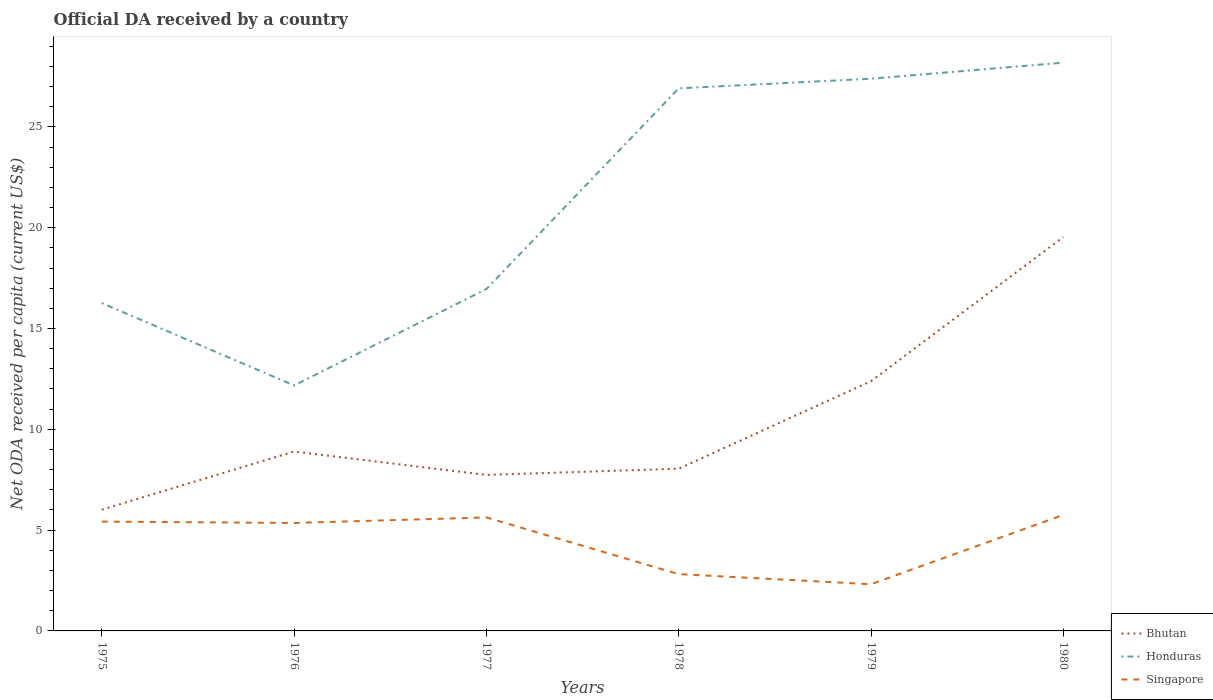Is the number of lines equal to the number of legend labels?
Offer a terse response. Yes. Across all years, what is the maximum ODA received in in Singapore?
Offer a terse response. 2.32. In which year was the ODA received in in Honduras maximum?
Provide a succinct answer. 1976. What is the total ODA received in in Singapore in the graph?
Keep it short and to the point. -0.27. What is the difference between the highest and the second highest ODA received in in Singapore?
Provide a short and direct response. 3.44. What is the difference between the highest and the lowest ODA received in in Singapore?
Provide a succinct answer. 4. Is the ODA received in in Singapore strictly greater than the ODA received in in Honduras over the years?
Provide a succinct answer. Yes. How many lines are there?
Keep it short and to the point. 3. Are the values on the major ticks of Y-axis written in scientific E-notation?
Your answer should be very brief. No. Does the graph contain grids?
Keep it short and to the point. No. How are the legend labels stacked?
Your response must be concise. Vertical. What is the title of the graph?
Give a very brief answer. Official DA received by a country. Does "Mali" appear as one of the legend labels in the graph?
Offer a very short reply. No. What is the label or title of the Y-axis?
Provide a succinct answer. Net ODA received per capita (current US$). What is the Net ODA received per capita (current US$) of Bhutan in 1975?
Your answer should be compact. 6.01. What is the Net ODA received per capita (current US$) of Honduras in 1975?
Keep it short and to the point. 16.26. What is the Net ODA received per capita (current US$) of Singapore in 1975?
Your response must be concise. 5.42. What is the Net ODA received per capita (current US$) of Bhutan in 1976?
Give a very brief answer. 8.9. What is the Net ODA received per capita (current US$) in Honduras in 1976?
Give a very brief answer. 12.18. What is the Net ODA received per capita (current US$) in Singapore in 1976?
Offer a terse response. 5.35. What is the Net ODA received per capita (current US$) of Bhutan in 1977?
Provide a succinct answer. 7.74. What is the Net ODA received per capita (current US$) of Honduras in 1977?
Provide a short and direct response. 16.96. What is the Net ODA received per capita (current US$) of Singapore in 1977?
Your answer should be very brief. 5.63. What is the Net ODA received per capita (current US$) of Bhutan in 1978?
Provide a succinct answer. 8.05. What is the Net ODA received per capita (current US$) in Honduras in 1978?
Give a very brief answer. 26.91. What is the Net ODA received per capita (current US$) in Singapore in 1978?
Provide a short and direct response. 2.82. What is the Net ODA received per capita (current US$) in Bhutan in 1979?
Your answer should be compact. 12.39. What is the Net ODA received per capita (current US$) of Honduras in 1979?
Provide a succinct answer. 27.39. What is the Net ODA received per capita (current US$) in Singapore in 1979?
Your response must be concise. 2.32. What is the Net ODA received per capita (current US$) of Bhutan in 1980?
Provide a succinct answer. 19.54. What is the Net ODA received per capita (current US$) in Honduras in 1980?
Ensure brevity in your answer.  28.19. What is the Net ODA received per capita (current US$) of Singapore in 1980?
Your answer should be compact. 5.75. Across all years, what is the maximum Net ODA received per capita (current US$) of Bhutan?
Offer a very short reply. 19.54. Across all years, what is the maximum Net ODA received per capita (current US$) of Honduras?
Keep it short and to the point. 28.19. Across all years, what is the maximum Net ODA received per capita (current US$) of Singapore?
Your response must be concise. 5.75. Across all years, what is the minimum Net ODA received per capita (current US$) in Bhutan?
Make the answer very short. 6.01. Across all years, what is the minimum Net ODA received per capita (current US$) in Honduras?
Provide a succinct answer. 12.18. Across all years, what is the minimum Net ODA received per capita (current US$) of Singapore?
Make the answer very short. 2.32. What is the total Net ODA received per capita (current US$) of Bhutan in the graph?
Give a very brief answer. 62.62. What is the total Net ODA received per capita (current US$) in Honduras in the graph?
Offer a terse response. 127.88. What is the total Net ODA received per capita (current US$) in Singapore in the graph?
Give a very brief answer. 27.29. What is the difference between the Net ODA received per capita (current US$) in Bhutan in 1975 and that in 1976?
Give a very brief answer. -2.88. What is the difference between the Net ODA received per capita (current US$) in Honduras in 1975 and that in 1976?
Provide a short and direct response. 4.09. What is the difference between the Net ODA received per capita (current US$) of Singapore in 1975 and that in 1976?
Give a very brief answer. 0.07. What is the difference between the Net ODA received per capita (current US$) in Bhutan in 1975 and that in 1977?
Offer a very short reply. -1.72. What is the difference between the Net ODA received per capita (current US$) of Honduras in 1975 and that in 1977?
Offer a terse response. -0.7. What is the difference between the Net ODA received per capita (current US$) in Singapore in 1975 and that in 1977?
Keep it short and to the point. -0.21. What is the difference between the Net ODA received per capita (current US$) of Bhutan in 1975 and that in 1978?
Provide a short and direct response. -2.03. What is the difference between the Net ODA received per capita (current US$) in Honduras in 1975 and that in 1978?
Provide a short and direct response. -10.65. What is the difference between the Net ODA received per capita (current US$) of Singapore in 1975 and that in 1978?
Your response must be concise. 2.61. What is the difference between the Net ODA received per capita (current US$) in Bhutan in 1975 and that in 1979?
Ensure brevity in your answer.  -6.37. What is the difference between the Net ODA received per capita (current US$) of Honduras in 1975 and that in 1979?
Offer a very short reply. -11.13. What is the difference between the Net ODA received per capita (current US$) of Singapore in 1975 and that in 1979?
Your answer should be compact. 3.11. What is the difference between the Net ODA received per capita (current US$) in Bhutan in 1975 and that in 1980?
Make the answer very short. -13.52. What is the difference between the Net ODA received per capita (current US$) of Honduras in 1975 and that in 1980?
Provide a short and direct response. -11.92. What is the difference between the Net ODA received per capita (current US$) of Singapore in 1975 and that in 1980?
Give a very brief answer. -0.33. What is the difference between the Net ODA received per capita (current US$) of Bhutan in 1976 and that in 1977?
Your answer should be very brief. 1.16. What is the difference between the Net ODA received per capita (current US$) of Honduras in 1976 and that in 1977?
Give a very brief answer. -4.78. What is the difference between the Net ODA received per capita (current US$) of Singapore in 1976 and that in 1977?
Give a very brief answer. -0.27. What is the difference between the Net ODA received per capita (current US$) in Bhutan in 1976 and that in 1978?
Give a very brief answer. 0.85. What is the difference between the Net ODA received per capita (current US$) of Honduras in 1976 and that in 1978?
Your answer should be compact. -14.74. What is the difference between the Net ODA received per capita (current US$) of Singapore in 1976 and that in 1978?
Offer a terse response. 2.54. What is the difference between the Net ODA received per capita (current US$) of Bhutan in 1976 and that in 1979?
Your answer should be very brief. -3.49. What is the difference between the Net ODA received per capita (current US$) in Honduras in 1976 and that in 1979?
Give a very brief answer. -15.21. What is the difference between the Net ODA received per capita (current US$) in Singapore in 1976 and that in 1979?
Ensure brevity in your answer.  3.04. What is the difference between the Net ODA received per capita (current US$) in Bhutan in 1976 and that in 1980?
Keep it short and to the point. -10.64. What is the difference between the Net ODA received per capita (current US$) in Honduras in 1976 and that in 1980?
Make the answer very short. -16.01. What is the difference between the Net ODA received per capita (current US$) in Singapore in 1976 and that in 1980?
Keep it short and to the point. -0.4. What is the difference between the Net ODA received per capita (current US$) of Bhutan in 1977 and that in 1978?
Ensure brevity in your answer.  -0.31. What is the difference between the Net ODA received per capita (current US$) in Honduras in 1977 and that in 1978?
Ensure brevity in your answer.  -9.95. What is the difference between the Net ODA received per capita (current US$) in Singapore in 1977 and that in 1978?
Your answer should be very brief. 2.81. What is the difference between the Net ODA received per capita (current US$) in Bhutan in 1977 and that in 1979?
Make the answer very short. -4.65. What is the difference between the Net ODA received per capita (current US$) of Honduras in 1977 and that in 1979?
Provide a short and direct response. -10.43. What is the difference between the Net ODA received per capita (current US$) in Singapore in 1977 and that in 1979?
Offer a very short reply. 3.31. What is the difference between the Net ODA received per capita (current US$) of Bhutan in 1977 and that in 1980?
Offer a terse response. -11.8. What is the difference between the Net ODA received per capita (current US$) of Honduras in 1977 and that in 1980?
Offer a terse response. -11.23. What is the difference between the Net ODA received per capita (current US$) of Singapore in 1977 and that in 1980?
Provide a short and direct response. -0.12. What is the difference between the Net ODA received per capita (current US$) of Bhutan in 1978 and that in 1979?
Provide a short and direct response. -4.34. What is the difference between the Net ODA received per capita (current US$) of Honduras in 1978 and that in 1979?
Keep it short and to the point. -0.48. What is the difference between the Net ODA received per capita (current US$) in Singapore in 1978 and that in 1979?
Keep it short and to the point. 0.5. What is the difference between the Net ODA received per capita (current US$) in Bhutan in 1978 and that in 1980?
Offer a very short reply. -11.49. What is the difference between the Net ODA received per capita (current US$) of Honduras in 1978 and that in 1980?
Offer a terse response. -1.27. What is the difference between the Net ODA received per capita (current US$) of Singapore in 1978 and that in 1980?
Give a very brief answer. -2.94. What is the difference between the Net ODA received per capita (current US$) in Bhutan in 1979 and that in 1980?
Provide a succinct answer. -7.15. What is the difference between the Net ODA received per capita (current US$) of Honduras in 1979 and that in 1980?
Your answer should be compact. -0.8. What is the difference between the Net ODA received per capita (current US$) in Singapore in 1979 and that in 1980?
Ensure brevity in your answer.  -3.44. What is the difference between the Net ODA received per capita (current US$) in Bhutan in 1975 and the Net ODA received per capita (current US$) in Honduras in 1976?
Your answer should be compact. -6.16. What is the difference between the Net ODA received per capita (current US$) of Bhutan in 1975 and the Net ODA received per capita (current US$) of Singapore in 1976?
Offer a terse response. 0.66. What is the difference between the Net ODA received per capita (current US$) of Honduras in 1975 and the Net ODA received per capita (current US$) of Singapore in 1976?
Provide a short and direct response. 10.91. What is the difference between the Net ODA received per capita (current US$) of Bhutan in 1975 and the Net ODA received per capita (current US$) of Honduras in 1977?
Provide a succinct answer. -10.94. What is the difference between the Net ODA received per capita (current US$) of Bhutan in 1975 and the Net ODA received per capita (current US$) of Singapore in 1977?
Provide a succinct answer. 0.39. What is the difference between the Net ODA received per capita (current US$) in Honduras in 1975 and the Net ODA received per capita (current US$) in Singapore in 1977?
Offer a very short reply. 10.63. What is the difference between the Net ODA received per capita (current US$) in Bhutan in 1975 and the Net ODA received per capita (current US$) in Honduras in 1978?
Your response must be concise. -20.9. What is the difference between the Net ODA received per capita (current US$) in Bhutan in 1975 and the Net ODA received per capita (current US$) in Singapore in 1978?
Your answer should be very brief. 3.2. What is the difference between the Net ODA received per capita (current US$) of Honduras in 1975 and the Net ODA received per capita (current US$) of Singapore in 1978?
Your answer should be very brief. 13.45. What is the difference between the Net ODA received per capita (current US$) of Bhutan in 1975 and the Net ODA received per capita (current US$) of Honduras in 1979?
Your response must be concise. -21.37. What is the difference between the Net ODA received per capita (current US$) of Bhutan in 1975 and the Net ODA received per capita (current US$) of Singapore in 1979?
Provide a short and direct response. 3.7. What is the difference between the Net ODA received per capita (current US$) in Honduras in 1975 and the Net ODA received per capita (current US$) in Singapore in 1979?
Offer a terse response. 13.95. What is the difference between the Net ODA received per capita (current US$) of Bhutan in 1975 and the Net ODA received per capita (current US$) of Honduras in 1980?
Keep it short and to the point. -22.17. What is the difference between the Net ODA received per capita (current US$) in Bhutan in 1975 and the Net ODA received per capita (current US$) in Singapore in 1980?
Your answer should be compact. 0.26. What is the difference between the Net ODA received per capita (current US$) of Honduras in 1975 and the Net ODA received per capita (current US$) of Singapore in 1980?
Make the answer very short. 10.51. What is the difference between the Net ODA received per capita (current US$) in Bhutan in 1976 and the Net ODA received per capita (current US$) in Honduras in 1977?
Provide a short and direct response. -8.06. What is the difference between the Net ODA received per capita (current US$) in Bhutan in 1976 and the Net ODA received per capita (current US$) in Singapore in 1977?
Offer a very short reply. 3.27. What is the difference between the Net ODA received per capita (current US$) of Honduras in 1976 and the Net ODA received per capita (current US$) of Singapore in 1977?
Make the answer very short. 6.55. What is the difference between the Net ODA received per capita (current US$) in Bhutan in 1976 and the Net ODA received per capita (current US$) in Honduras in 1978?
Offer a very short reply. -18.01. What is the difference between the Net ODA received per capita (current US$) of Bhutan in 1976 and the Net ODA received per capita (current US$) of Singapore in 1978?
Ensure brevity in your answer.  6.08. What is the difference between the Net ODA received per capita (current US$) of Honduras in 1976 and the Net ODA received per capita (current US$) of Singapore in 1978?
Keep it short and to the point. 9.36. What is the difference between the Net ODA received per capita (current US$) in Bhutan in 1976 and the Net ODA received per capita (current US$) in Honduras in 1979?
Your answer should be very brief. -18.49. What is the difference between the Net ODA received per capita (current US$) in Bhutan in 1976 and the Net ODA received per capita (current US$) in Singapore in 1979?
Offer a very short reply. 6.58. What is the difference between the Net ODA received per capita (current US$) in Honduras in 1976 and the Net ODA received per capita (current US$) in Singapore in 1979?
Give a very brief answer. 9.86. What is the difference between the Net ODA received per capita (current US$) in Bhutan in 1976 and the Net ODA received per capita (current US$) in Honduras in 1980?
Keep it short and to the point. -19.29. What is the difference between the Net ODA received per capita (current US$) in Bhutan in 1976 and the Net ODA received per capita (current US$) in Singapore in 1980?
Your answer should be compact. 3.14. What is the difference between the Net ODA received per capita (current US$) in Honduras in 1976 and the Net ODA received per capita (current US$) in Singapore in 1980?
Your answer should be very brief. 6.42. What is the difference between the Net ODA received per capita (current US$) in Bhutan in 1977 and the Net ODA received per capita (current US$) in Honduras in 1978?
Your response must be concise. -19.17. What is the difference between the Net ODA received per capita (current US$) in Bhutan in 1977 and the Net ODA received per capita (current US$) in Singapore in 1978?
Your answer should be compact. 4.92. What is the difference between the Net ODA received per capita (current US$) in Honduras in 1977 and the Net ODA received per capita (current US$) in Singapore in 1978?
Ensure brevity in your answer.  14.14. What is the difference between the Net ODA received per capita (current US$) of Bhutan in 1977 and the Net ODA received per capita (current US$) of Honduras in 1979?
Provide a succinct answer. -19.65. What is the difference between the Net ODA received per capita (current US$) of Bhutan in 1977 and the Net ODA received per capita (current US$) of Singapore in 1979?
Keep it short and to the point. 5.42. What is the difference between the Net ODA received per capita (current US$) in Honduras in 1977 and the Net ODA received per capita (current US$) in Singapore in 1979?
Provide a short and direct response. 14.64. What is the difference between the Net ODA received per capita (current US$) in Bhutan in 1977 and the Net ODA received per capita (current US$) in Honduras in 1980?
Your answer should be very brief. -20.45. What is the difference between the Net ODA received per capita (current US$) of Bhutan in 1977 and the Net ODA received per capita (current US$) of Singapore in 1980?
Your answer should be compact. 1.98. What is the difference between the Net ODA received per capita (current US$) in Honduras in 1977 and the Net ODA received per capita (current US$) in Singapore in 1980?
Your answer should be compact. 11.2. What is the difference between the Net ODA received per capita (current US$) of Bhutan in 1978 and the Net ODA received per capita (current US$) of Honduras in 1979?
Your answer should be compact. -19.34. What is the difference between the Net ODA received per capita (current US$) of Bhutan in 1978 and the Net ODA received per capita (current US$) of Singapore in 1979?
Provide a short and direct response. 5.73. What is the difference between the Net ODA received per capita (current US$) of Honduras in 1978 and the Net ODA received per capita (current US$) of Singapore in 1979?
Your response must be concise. 24.6. What is the difference between the Net ODA received per capita (current US$) in Bhutan in 1978 and the Net ODA received per capita (current US$) in Honduras in 1980?
Your response must be concise. -20.14. What is the difference between the Net ODA received per capita (current US$) in Bhutan in 1978 and the Net ODA received per capita (current US$) in Singapore in 1980?
Provide a succinct answer. 2.29. What is the difference between the Net ODA received per capita (current US$) of Honduras in 1978 and the Net ODA received per capita (current US$) of Singapore in 1980?
Your answer should be compact. 21.16. What is the difference between the Net ODA received per capita (current US$) of Bhutan in 1979 and the Net ODA received per capita (current US$) of Honduras in 1980?
Your answer should be compact. -15.8. What is the difference between the Net ODA received per capita (current US$) in Bhutan in 1979 and the Net ODA received per capita (current US$) in Singapore in 1980?
Your answer should be very brief. 6.63. What is the difference between the Net ODA received per capita (current US$) in Honduras in 1979 and the Net ODA received per capita (current US$) in Singapore in 1980?
Keep it short and to the point. 21.64. What is the average Net ODA received per capita (current US$) in Bhutan per year?
Provide a succinct answer. 10.44. What is the average Net ODA received per capita (current US$) of Honduras per year?
Provide a succinct answer. 21.31. What is the average Net ODA received per capita (current US$) in Singapore per year?
Ensure brevity in your answer.  4.55. In the year 1975, what is the difference between the Net ODA received per capita (current US$) in Bhutan and Net ODA received per capita (current US$) in Honduras?
Ensure brevity in your answer.  -10.25. In the year 1975, what is the difference between the Net ODA received per capita (current US$) of Bhutan and Net ODA received per capita (current US$) of Singapore?
Your response must be concise. 0.59. In the year 1975, what is the difference between the Net ODA received per capita (current US$) of Honduras and Net ODA received per capita (current US$) of Singapore?
Provide a short and direct response. 10.84. In the year 1976, what is the difference between the Net ODA received per capita (current US$) of Bhutan and Net ODA received per capita (current US$) of Honduras?
Offer a very short reply. -3.28. In the year 1976, what is the difference between the Net ODA received per capita (current US$) of Bhutan and Net ODA received per capita (current US$) of Singapore?
Offer a terse response. 3.54. In the year 1976, what is the difference between the Net ODA received per capita (current US$) in Honduras and Net ODA received per capita (current US$) in Singapore?
Your response must be concise. 6.82. In the year 1977, what is the difference between the Net ODA received per capita (current US$) of Bhutan and Net ODA received per capita (current US$) of Honduras?
Give a very brief answer. -9.22. In the year 1977, what is the difference between the Net ODA received per capita (current US$) in Bhutan and Net ODA received per capita (current US$) in Singapore?
Provide a short and direct response. 2.11. In the year 1977, what is the difference between the Net ODA received per capita (current US$) of Honduras and Net ODA received per capita (current US$) of Singapore?
Keep it short and to the point. 11.33. In the year 1978, what is the difference between the Net ODA received per capita (current US$) in Bhutan and Net ODA received per capita (current US$) in Honduras?
Keep it short and to the point. -18.86. In the year 1978, what is the difference between the Net ODA received per capita (current US$) in Bhutan and Net ODA received per capita (current US$) in Singapore?
Make the answer very short. 5.23. In the year 1978, what is the difference between the Net ODA received per capita (current US$) of Honduras and Net ODA received per capita (current US$) of Singapore?
Your response must be concise. 24.09. In the year 1979, what is the difference between the Net ODA received per capita (current US$) in Bhutan and Net ODA received per capita (current US$) in Honduras?
Give a very brief answer. -15. In the year 1979, what is the difference between the Net ODA received per capita (current US$) in Bhutan and Net ODA received per capita (current US$) in Singapore?
Keep it short and to the point. 10.07. In the year 1979, what is the difference between the Net ODA received per capita (current US$) of Honduras and Net ODA received per capita (current US$) of Singapore?
Provide a succinct answer. 25.07. In the year 1980, what is the difference between the Net ODA received per capita (current US$) in Bhutan and Net ODA received per capita (current US$) in Honduras?
Ensure brevity in your answer.  -8.65. In the year 1980, what is the difference between the Net ODA received per capita (current US$) of Bhutan and Net ODA received per capita (current US$) of Singapore?
Your answer should be very brief. 13.78. In the year 1980, what is the difference between the Net ODA received per capita (current US$) in Honduras and Net ODA received per capita (current US$) in Singapore?
Your answer should be compact. 22.43. What is the ratio of the Net ODA received per capita (current US$) in Bhutan in 1975 to that in 1976?
Provide a succinct answer. 0.68. What is the ratio of the Net ODA received per capita (current US$) of Honduras in 1975 to that in 1976?
Provide a short and direct response. 1.34. What is the ratio of the Net ODA received per capita (current US$) in Singapore in 1975 to that in 1976?
Provide a succinct answer. 1.01. What is the ratio of the Net ODA received per capita (current US$) of Bhutan in 1975 to that in 1977?
Your answer should be compact. 0.78. What is the ratio of the Net ODA received per capita (current US$) in Singapore in 1975 to that in 1977?
Offer a very short reply. 0.96. What is the ratio of the Net ODA received per capita (current US$) of Bhutan in 1975 to that in 1978?
Your response must be concise. 0.75. What is the ratio of the Net ODA received per capita (current US$) in Honduras in 1975 to that in 1978?
Offer a terse response. 0.6. What is the ratio of the Net ODA received per capita (current US$) in Singapore in 1975 to that in 1978?
Provide a succinct answer. 1.93. What is the ratio of the Net ODA received per capita (current US$) of Bhutan in 1975 to that in 1979?
Your response must be concise. 0.49. What is the ratio of the Net ODA received per capita (current US$) of Honduras in 1975 to that in 1979?
Keep it short and to the point. 0.59. What is the ratio of the Net ODA received per capita (current US$) in Singapore in 1975 to that in 1979?
Provide a succinct answer. 2.34. What is the ratio of the Net ODA received per capita (current US$) of Bhutan in 1975 to that in 1980?
Keep it short and to the point. 0.31. What is the ratio of the Net ODA received per capita (current US$) of Honduras in 1975 to that in 1980?
Your answer should be compact. 0.58. What is the ratio of the Net ODA received per capita (current US$) in Singapore in 1975 to that in 1980?
Offer a terse response. 0.94. What is the ratio of the Net ODA received per capita (current US$) in Bhutan in 1976 to that in 1977?
Your response must be concise. 1.15. What is the ratio of the Net ODA received per capita (current US$) in Honduras in 1976 to that in 1977?
Keep it short and to the point. 0.72. What is the ratio of the Net ODA received per capita (current US$) in Singapore in 1976 to that in 1977?
Offer a very short reply. 0.95. What is the ratio of the Net ODA received per capita (current US$) of Bhutan in 1976 to that in 1978?
Keep it short and to the point. 1.11. What is the ratio of the Net ODA received per capita (current US$) in Honduras in 1976 to that in 1978?
Keep it short and to the point. 0.45. What is the ratio of the Net ODA received per capita (current US$) in Singapore in 1976 to that in 1978?
Provide a succinct answer. 1.9. What is the ratio of the Net ODA received per capita (current US$) of Bhutan in 1976 to that in 1979?
Offer a very short reply. 0.72. What is the ratio of the Net ODA received per capita (current US$) of Honduras in 1976 to that in 1979?
Provide a succinct answer. 0.44. What is the ratio of the Net ODA received per capita (current US$) in Singapore in 1976 to that in 1979?
Provide a short and direct response. 2.31. What is the ratio of the Net ODA received per capita (current US$) in Bhutan in 1976 to that in 1980?
Provide a succinct answer. 0.46. What is the ratio of the Net ODA received per capita (current US$) of Honduras in 1976 to that in 1980?
Your response must be concise. 0.43. What is the ratio of the Net ODA received per capita (current US$) of Singapore in 1976 to that in 1980?
Keep it short and to the point. 0.93. What is the ratio of the Net ODA received per capita (current US$) of Bhutan in 1977 to that in 1978?
Provide a short and direct response. 0.96. What is the ratio of the Net ODA received per capita (current US$) of Honduras in 1977 to that in 1978?
Your response must be concise. 0.63. What is the ratio of the Net ODA received per capita (current US$) in Singapore in 1977 to that in 1978?
Provide a succinct answer. 2. What is the ratio of the Net ODA received per capita (current US$) in Bhutan in 1977 to that in 1979?
Give a very brief answer. 0.62. What is the ratio of the Net ODA received per capita (current US$) in Honduras in 1977 to that in 1979?
Make the answer very short. 0.62. What is the ratio of the Net ODA received per capita (current US$) in Singapore in 1977 to that in 1979?
Offer a terse response. 2.43. What is the ratio of the Net ODA received per capita (current US$) in Bhutan in 1977 to that in 1980?
Provide a succinct answer. 0.4. What is the ratio of the Net ODA received per capita (current US$) of Honduras in 1977 to that in 1980?
Give a very brief answer. 0.6. What is the ratio of the Net ODA received per capita (current US$) of Singapore in 1977 to that in 1980?
Keep it short and to the point. 0.98. What is the ratio of the Net ODA received per capita (current US$) in Bhutan in 1978 to that in 1979?
Your response must be concise. 0.65. What is the ratio of the Net ODA received per capita (current US$) of Honduras in 1978 to that in 1979?
Give a very brief answer. 0.98. What is the ratio of the Net ODA received per capita (current US$) in Singapore in 1978 to that in 1979?
Make the answer very short. 1.22. What is the ratio of the Net ODA received per capita (current US$) in Bhutan in 1978 to that in 1980?
Your answer should be compact. 0.41. What is the ratio of the Net ODA received per capita (current US$) of Honduras in 1978 to that in 1980?
Make the answer very short. 0.95. What is the ratio of the Net ODA received per capita (current US$) in Singapore in 1978 to that in 1980?
Offer a very short reply. 0.49. What is the ratio of the Net ODA received per capita (current US$) in Bhutan in 1979 to that in 1980?
Keep it short and to the point. 0.63. What is the ratio of the Net ODA received per capita (current US$) of Honduras in 1979 to that in 1980?
Offer a terse response. 0.97. What is the ratio of the Net ODA received per capita (current US$) of Singapore in 1979 to that in 1980?
Provide a short and direct response. 0.4. What is the difference between the highest and the second highest Net ODA received per capita (current US$) in Bhutan?
Keep it short and to the point. 7.15. What is the difference between the highest and the second highest Net ODA received per capita (current US$) of Honduras?
Your response must be concise. 0.8. What is the difference between the highest and the second highest Net ODA received per capita (current US$) in Singapore?
Offer a terse response. 0.12. What is the difference between the highest and the lowest Net ODA received per capita (current US$) of Bhutan?
Ensure brevity in your answer.  13.52. What is the difference between the highest and the lowest Net ODA received per capita (current US$) of Honduras?
Your answer should be compact. 16.01. What is the difference between the highest and the lowest Net ODA received per capita (current US$) in Singapore?
Your answer should be compact. 3.44. 